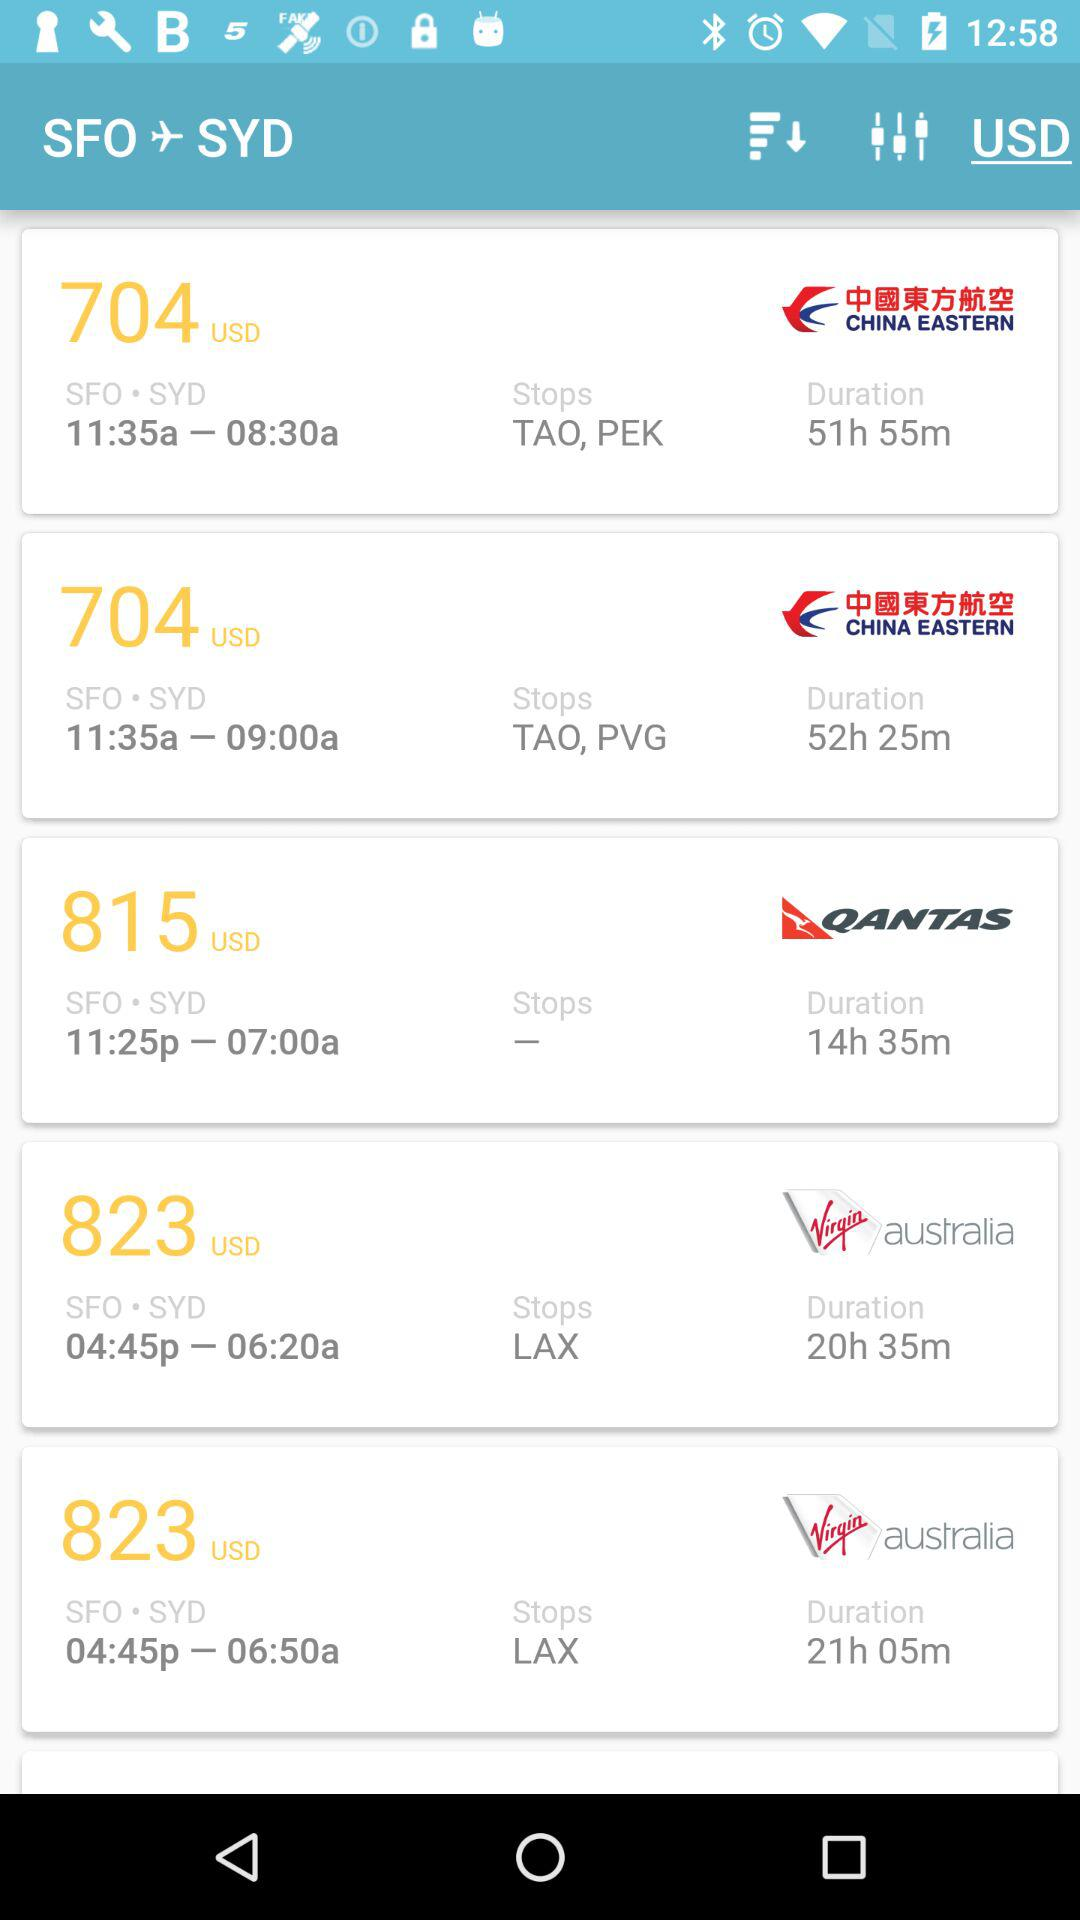Which airline has the most stops?
Answer the question using a single word or phrase. China Eastern 